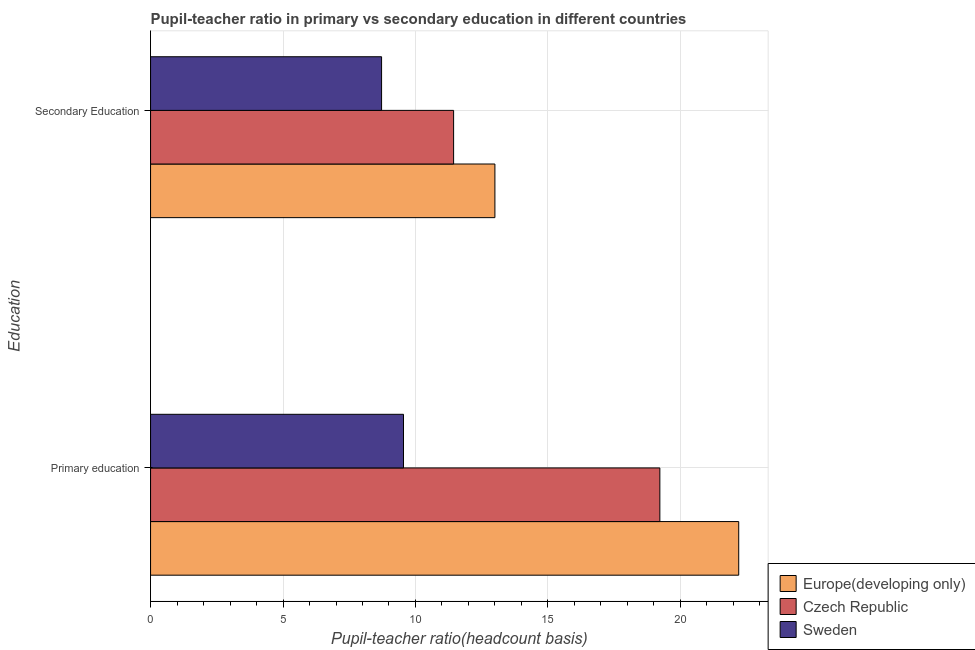How many different coloured bars are there?
Provide a succinct answer. 3. How many groups of bars are there?
Your response must be concise. 2. Are the number of bars per tick equal to the number of legend labels?
Your answer should be compact. Yes. Are the number of bars on each tick of the Y-axis equal?
Give a very brief answer. Yes. How many bars are there on the 2nd tick from the top?
Make the answer very short. 3. What is the label of the 2nd group of bars from the top?
Your answer should be compact. Primary education. What is the pupil teacher ratio on secondary education in Czech Republic?
Provide a succinct answer. 11.44. Across all countries, what is the maximum pupil teacher ratio on secondary education?
Keep it short and to the point. 13. Across all countries, what is the minimum pupil-teacher ratio in primary education?
Give a very brief answer. 9.55. In which country was the pupil-teacher ratio in primary education maximum?
Offer a very short reply. Europe(developing only). In which country was the pupil teacher ratio on secondary education minimum?
Your answer should be compact. Sweden. What is the total pupil teacher ratio on secondary education in the graph?
Ensure brevity in your answer.  33.16. What is the difference between the pupil teacher ratio on secondary education in Sweden and that in Europe(developing only)?
Give a very brief answer. -4.28. What is the difference between the pupil teacher ratio on secondary education in Europe(developing only) and the pupil-teacher ratio in primary education in Sweden?
Give a very brief answer. 3.45. What is the average pupil teacher ratio on secondary education per country?
Ensure brevity in your answer.  11.05. What is the difference between the pupil-teacher ratio in primary education and pupil teacher ratio on secondary education in Sweden?
Make the answer very short. 0.83. What is the ratio of the pupil-teacher ratio in primary education in Czech Republic to that in Europe(developing only)?
Give a very brief answer. 0.87. In how many countries, is the pupil-teacher ratio in primary education greater than the average pupil-teacher ratio in primary education taken over all countries?
Your response must be concise. 2. What does the 2nd bar from the top in Secondary Education represents?
Your answer should be compact. Czech Republic. What does the 3rd bar from the bottom in Primary education represents?
Keep it short and to the point. Sweden. How many bars are there?
Provide a succinct answer. 6. How many countries are there in the graph?
Your answer should be very brief. 3. Where does the legend appear in the graph?
Provide a short and direct response. Bottom right. What is the title of the graph?
Keep it short and to the point. Pupil-teacher ratio in primary vs secondary education in different countries. What is the label or title of the X-axis?
Your response must be concise. Pupil-teacher ratio(headcount basis). What is the label or title of the Y-axis?
Ensure brevity in your answer.  Education. What is the Pupil-teacher ratio(headcount basis) of Europe(developing only) in Primary education?
Ensure brevity in your answer.  22.2. What is the Pupil-teacher ratio(headcount basis) in Czech Republic in Primary education?
Your answer should be compact. 19.23. What is the Pupil-teacher ratio(headcount basis) of Sweden in Primary education?
Offer a very short reply. 9.55. What is the Pupil-teacher ratio(headcount basis) in Europe(developing only) in Secondary Education?
Ensure brevity in your answer.  13. What is the Pupil-teacher ratio(headcount basis) of Czech Republic in Secondary Education?
Provide a short and direct response. 11.44. What is the Pupil-teacher ratio(headcount basis) of Sweden in Secondary Education?
Offer a terse response. 8.72. Across all Education, what is the maximum Pupil-teacher ratio(headcount basis) of Europe(developing only)?
Offer a very short reply. 22.2. Across all Education, what is the maximum Pupil-teacher ratio(headcount basis) in Czech Republic?
Provide a short and direct response. 19.23. Across all Education, what is the maximum Pupil-teacher ratio(headcount basis) of Sweden?
Provide a succinct answer. 9.55. Across all Education, what is the minimum Pupil-teacher ratio(headcount basis) of Europe(developing only)?
Make the answer very short. 13. Across all Education, what is the minimum Pupil-teacher ratio(headcount basis) in Czech Republic?
Offer a terse response. 11.44. Across all Education, what is the minimum Pupil-teacher ratio(headcount basis) in Sweden?
Your answer should be compact. 8.72. What is the total Pupil-teacher ratio(headcount basis) of Europe(developing only) in the graph?
Give a very brief answer. 35.2. What is the total Pupil-teacher ratio(headcount basis) of Czech Republic in the graph?
Provide a succinct answer. 30.67. What is the total Pupil-teacher ratio(headcount basis) in Sweden in the graph?
Ensure brevity in your answer.  18.27. What is the difference between the Pupil-teacher ratio(headcount basis) in Europe(developing only) in Primary education and that in Secondary Education?
Your response must be concise. 9.2. What is the difference between the Pupil-teacher ratio(headcount basis) in Czech Republic in Primary education and that in Secondary Education?
Make the answer very short. 7.79. What is the difference between the Pupil-teacher ratio(headcount basis) in Sweden in Primary education and that in Secondary Education?
Offer a very short reply. 0.83. What is the difference between the Pupil-teacher ratio(headcount basis) of Europe(developing only) in Primary education and the Pupil-teacher ratio(headcount basis) of Czech Republic in Secondary Education?
Keep it short and to the point. 10.76. What is the difference between the Pupil-teacher ratio(headcount basis) of Europe(developing only) in Primary education and the Pupil-teacher ratio(headcount basis) of Sweden in Secondary Education?
Make the answer very short. 13.48. What is the difference between the Pupil-teacher ratio(headcount basis) of Czech Republic in Primary education and the Pupil-teacher ratio(headcount basis) of Sweden in Secondary Education?
Offer a terse response. 10.51. What is the average Pupil-teacher ratio(headcount basis) of Europe(developing only) per Education?
Offer a very short reply. 17.6. What is the average Pupil-teacher ratio(headcount basis) of Czech Republic per Education?
Your answer should be very brief. 15.33. What is the average Pupil-teacher ratio(headcount basis) in Sweden per Education?
Provide a short and direct response. 9.13. What is the difference between the Pupil-teacher ratio(headcount basis) in Europe(developing only) and Pupil-teacher ratio(headcount basis) in Czech Republic in Primary education?
Your answer should be very brief. 2.98. What is the difference between the Pupil-teacher ratio(headcount basis) in Europe(developing only) and Pupil-teacher ratio(headcount basis) in Sweden in Primary education?
Your answer should be compact. 12.65. What is the difference between the Pupil-teacher ratio(headcount basis) of Czech Republic and Pupil-teacher ratio(headcount basis) of Sweden in Primary education?
Ensure brevity in your answer.  9.68. What is the difference between the Pupil-teacher ratio(headcount basis) in Europe(developing only) and Pupil-teacher ratio(headcount basis) in Czech Republic in Secondary Education?
Your response must be concise. 1.56. What is the difference between the Pupil-teacher ratio(headcount basis) of Europe(developing only) and Pupil-teacher ratio(headcount basis) of Sweden in Secondary Education?
Keep it short and to the point. 4.28. What is the difference between the Pupil-teacher ratio(headcount basis) of Czech Republic and Pupil-teacher ratio(headcount basis) of Sweden in Secondary Education?
Offer a terse response. 2.72. What is the ratio of the Pupil-teacher ratio(headcount basis) of Europe(developing only) in Primary education to that in Secondary Education?
Offer a terse response. 1.71. What is the ratio of the Pupil-teacher ratio(headcount basis) in Czech Republic in Primary education to that in Secondary Education?
Your answer should be very brief. 1.68. What is the ratio of the Pupil-teacher ratio(headcount basis) in Sweden in Primary education to that in Secondary Education?
Offer a terse response. 1.09. What is the difference between the highest and the second highest Pupil-teacher ratio(headcount basis) in Europe(developing only)?
Make the answer very short. 9.2. What is the difference between the highest and the second highest Pupil-teacher ratio(headcount basis) in Czech Republic?
Your answer should be compact. 7.79. What is the difference between the highest and the second highest Pupil-teacher ratio(headcount basis) of Sweden?
Provide a succinct answer. 0.83. What is the difference between the highest and the lowest Pupil-teacher ratio(headcount basis) of Europe(developing only)?
Offer a terse response. 9.2. What is the difference between the highest and the lowest Pupil-teacher ratio(headcount basis) in Czech Republic?
Provide a short and direct response. 7.79. What is the difference between the highest and the lowest Pupil-teacher ratio(headcount basis) in Sweden?
Offer a terse response. 0.83. 